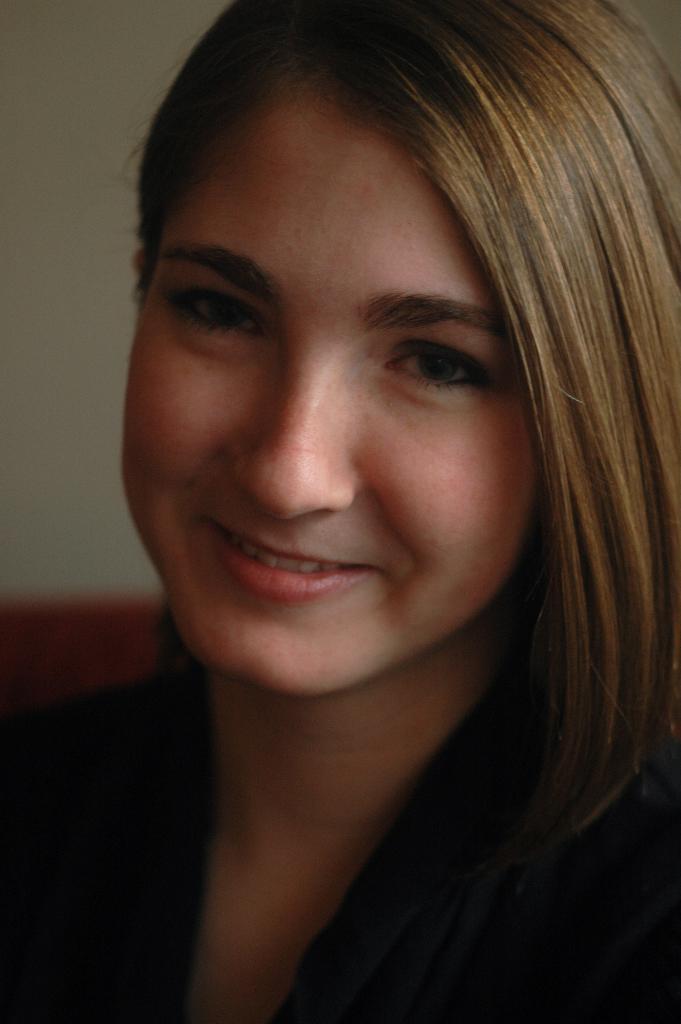Could you give a brief overview of what you see in this image? In this picture there is a woman smiling. In the background of the image we can see wall. 